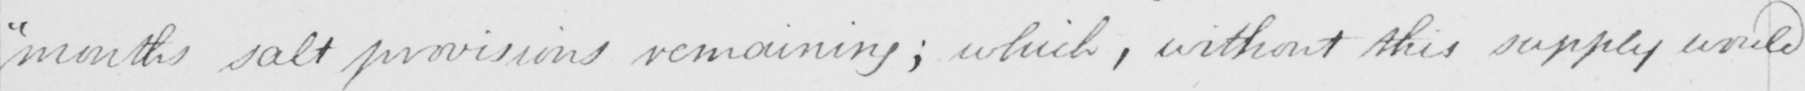Can you read and transcribe this handwriting? months salt provisions remaining ; which , without this supply would 